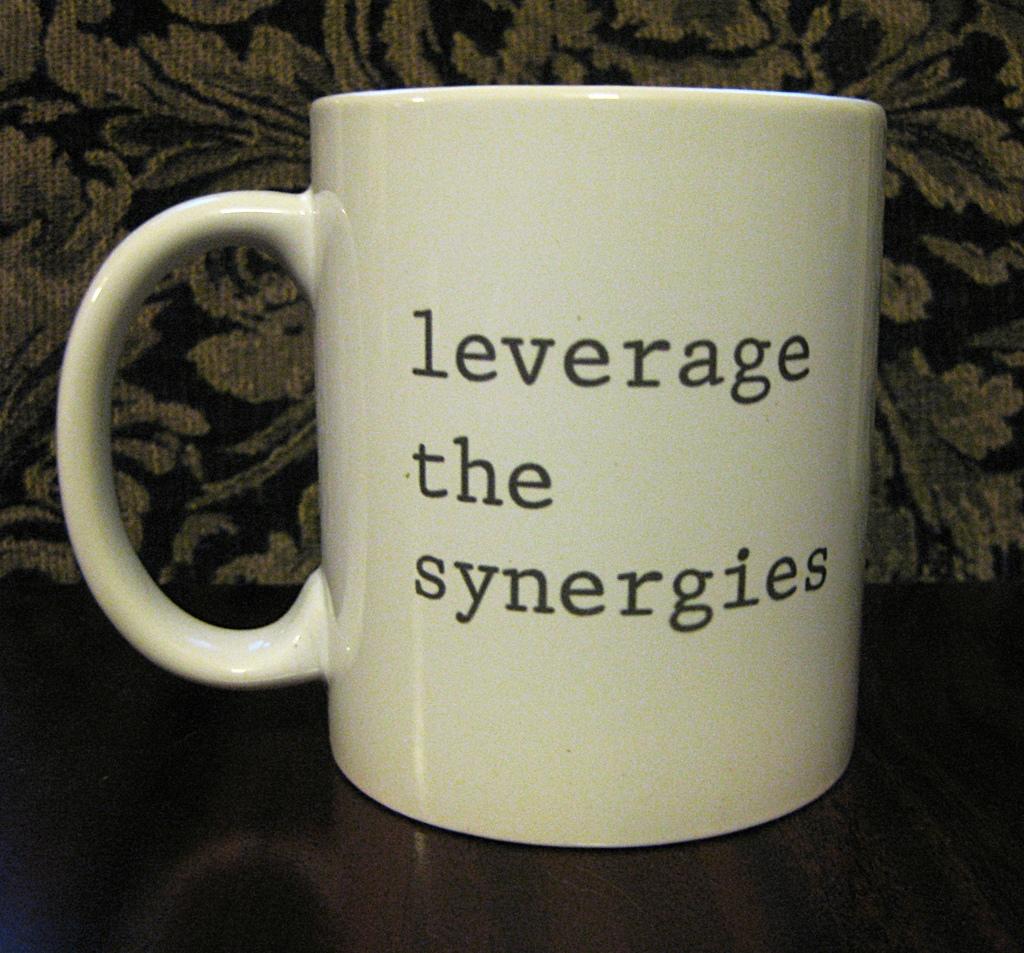What should you leverage?
Give a very brief answer. The synergies. What should you do?
Provide a succinct answer. Leverage the synergies. 